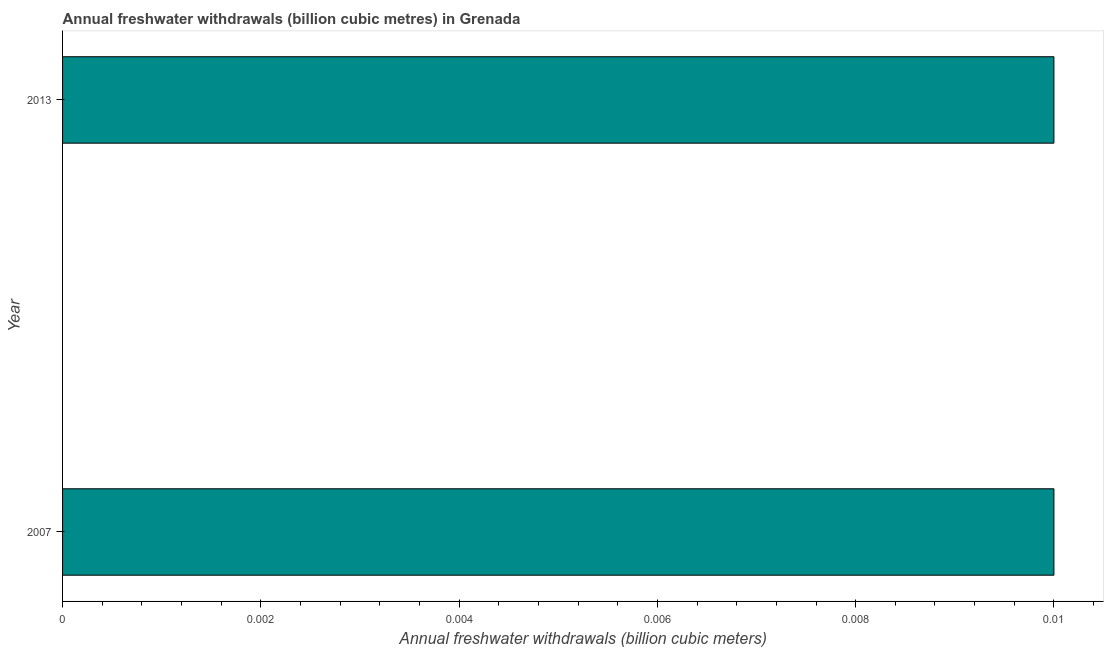Does the graph contain any zero values?
Keep it short and to the point. No. Does the graph contain grids?
Make the answer very short. No. What is the title of the graph?
Your response must be concise. Annual freshwater withdrawals (billion cubic metres) in Grenada. What is the label or title of the X-axis?
Keep it short and to the point. Annual freshwater withdrawals (billion cubic meters). What is the label or title of the Y-axis?
Your answer should be compact. Year. What is the annual freshwater withdrawals in 2013?
Your answer should be very brief. 0.01. Across all years, what is the maximum annual freshwater withdrawals?
Your answer should be very brief. 0.01. In which year was the annual freshwater withdrawals maximum?
Keep it short and to the point. 2007. What is the sum of the annual freshwater withdrawals?
Your answer should be compact. 0.02. What is the average annual freshwater withdrawals per year?
Ensure brevity in your answer.  0.01. What is the median annual freshwater withdrawals?
Give a very brief answer. 0.01. How many bars are there?
Give a very brief answer. 2. Are all the bars in the graph horizontal?
Your answer should be compact. Yes. How many years are there in the graph?
Your answer should be compact. 2. What is the difference between two consecutive major ticks on the X-axis?
Your answer should be compact. 0. What is the Annual freshwater withdrawals (billion cubic meters) of 2007?
Your answer should be compact. 0.01. What is the ratio of the Annual freshwater withdrawals (billion cubic meters) in 2007 to that in 2013?
Provide a succinct answer. 1. 